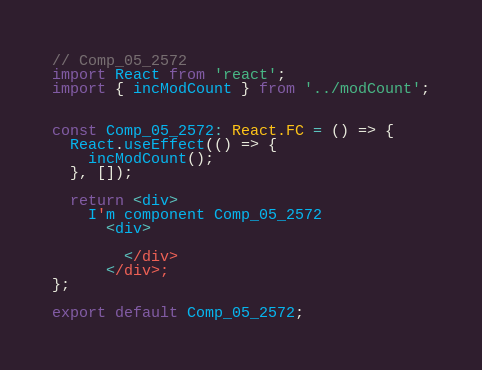Convert code to text. <code><loc_0><loc_0><loc_500><loc_500><_TypeScript_>// Comp_05_2572
import React from 'react';
import { incModCount } from '../modCount';


const Comp_05_2572: React.FC = () => {
  React.useEffect(() => {
    incModCount();
  }, []);

  return <div>
    I'm component Comp_05_2572
      <div>
      
        </div>
      </div>;
};

export default Comp_05_2572;
</code> 